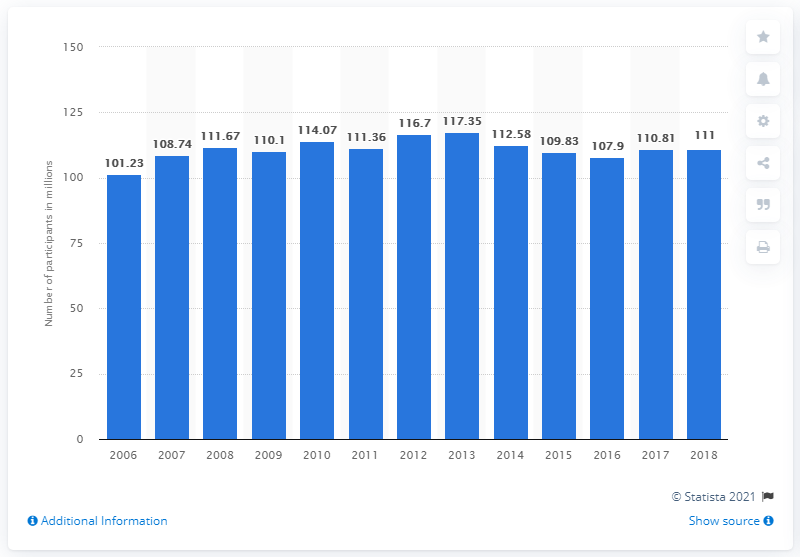Outline some significant characteristics in this image. In 2018, 111 million people in the United States were engaged in walking as a form of fitness. 